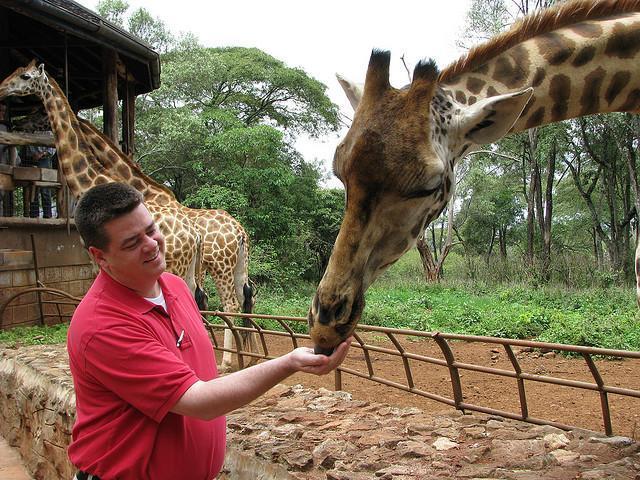How many people are there?
Give a very brief answer. 1. How many giraffes are in the photo?
Give a very brief answer. 3. 